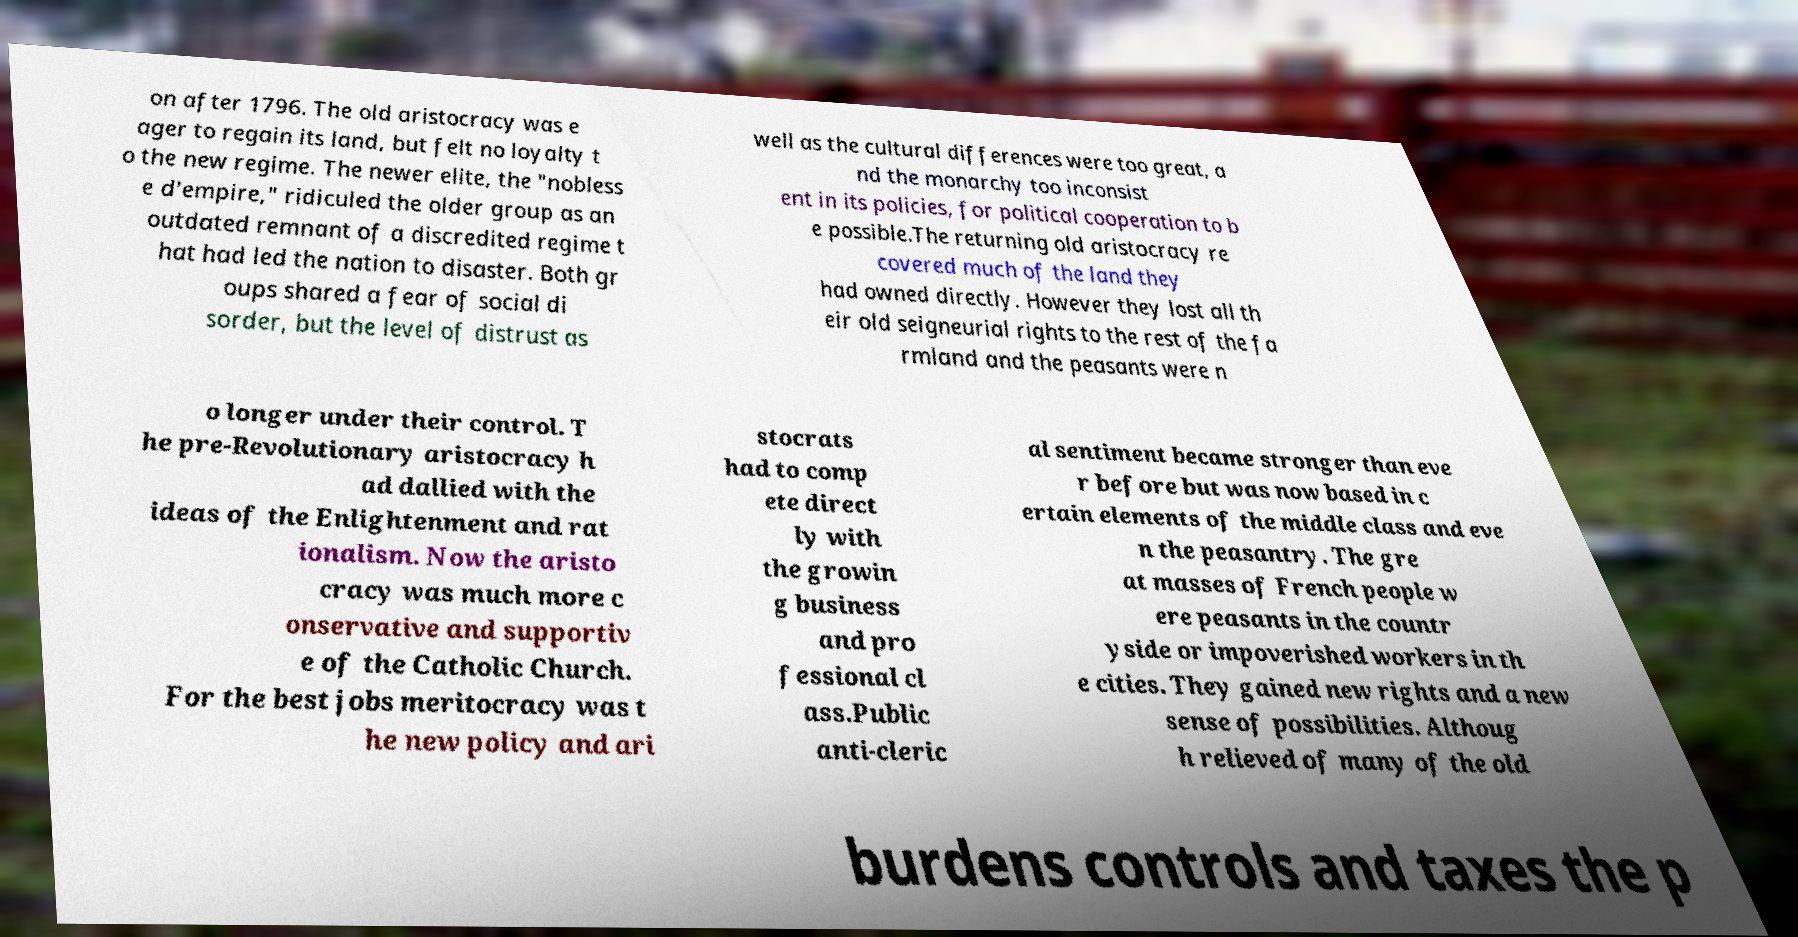Please read and relay the text visible in this image. What does it say? on after 1796. The old aristocracy was e ager to regain its land, but felt no loyalty t o the new regime. The newer elite, the "nobless e d'empire," ridiculed the older group as an outdated remnant of a discredited regime t hat had led the nation to disaster. Both gr oups shared a fear of social di sorder, but the level of distrust as well as the cultural differences were too great, a nd the monarchy too inconsist ent in its policies, for political cooperation to b e possible.The returning old aristocracy re covered much of the land they had owned directly. However they lost all th eir old seigneurial rights to the rest of the fa rmland and the peasants were n o longer under their control. T he pre-Revolutionary aristocracy h ad dallied with the ideas of the Enlightenment and rat ionalism. Now the aristo cracy was much more c onservative and supportiv e of the Catholic Church. For the best jobs meritocracy was t he new policy and ari stocrats had to comp ete direct ly with the growin g business and pro fessional cl ass.Public anti-cleric al sentiment became stronger than eve r before but was now based in c ertain elements of the middle class and eve n the peasantry. The gre at masses of French people w ere peasants in the countr yside or impoverished workers in th e cities. They gained new rights and a new sense of possibilities. Althoug h relieved of many of the old burdens controls and taxes the p 